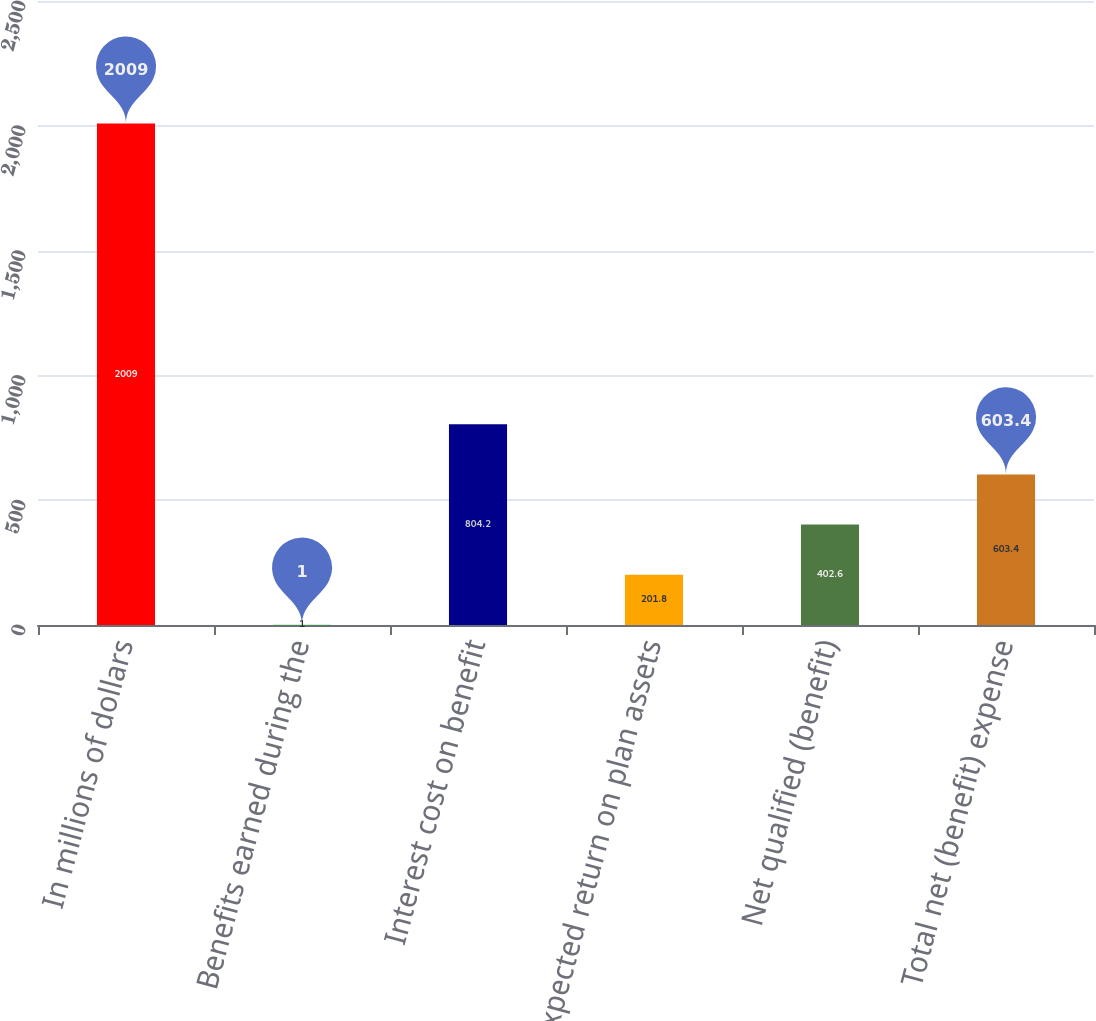<chart> <loc_0><loc_0><loc_500><loc_500><bar_chart><fcel>In millions of dollars<fcel>Benefits earned during the<fcel>Interest cost on benefit<fcel>Expected return on plan assets<fcel>Net qualified (benefit)<fcel>Total net (benefit) expense<nl><fcel>2009<fcel>1<fcel>804.2<fcel>201.8<fcel>402.6<fcel>603.4<nl></chart> 